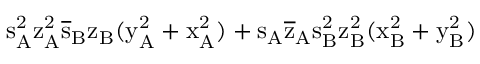<formula> <loc_0><loc_0><loc_500><loc_500>s _ { A } ^ { 2 } \mathrm { z _ { A } ^ { 2 } \mathrm { \overline { s } _ { B } \mathrm { z _ { B } ( \mathrm { y _ { A } ^ { 2 } + \mathrm { x _ { A } ^ { 2 } ) + \mathrm { s _ { A } \mathrm { \overline { z } _ { A } \mathrm { s _ { B } ^ { 2 } \mathrm { z _ { B } ^ { 2 } ( \mathrm { x _ { B } ^ { 2 } + \mathrm { y _ { B } ^ { 2 } ) } } } } } } } } } } }</formula> 